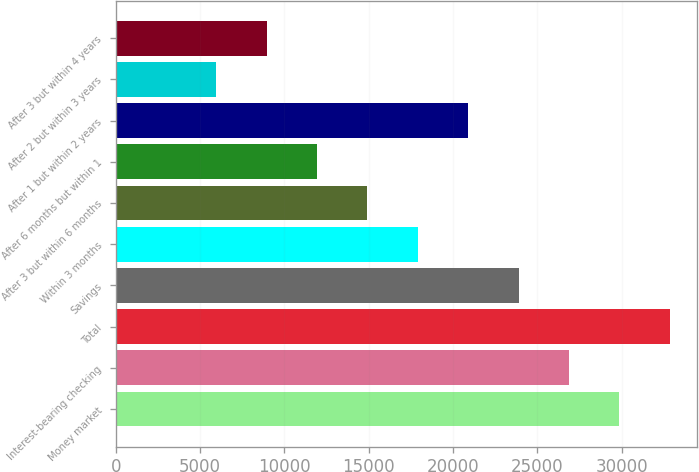<chart> <loc_0><loc_0><loc_500><loc_500><bar_chart><fcel>Money market<fcel>Interest-bearing checking<fcel>Total<fcel>Savings<fcel>Within 3 months<fcel>After 3 but within 6 months<fcel>After 6 months but within 1<fcel>After 1 but within 2 years<fcel>After 2 but within 3 years<fcel>After 3 but within 4 years<nl><fcel>29860.8<fcel>26874.7<fcel>32846.9<fcel>23888.7<fcel>17916.5<fcel>14930.5<fcel>11944.4<fcel>20902.6<fcel>5972.24<fcel>8958.31<nl></chart> 